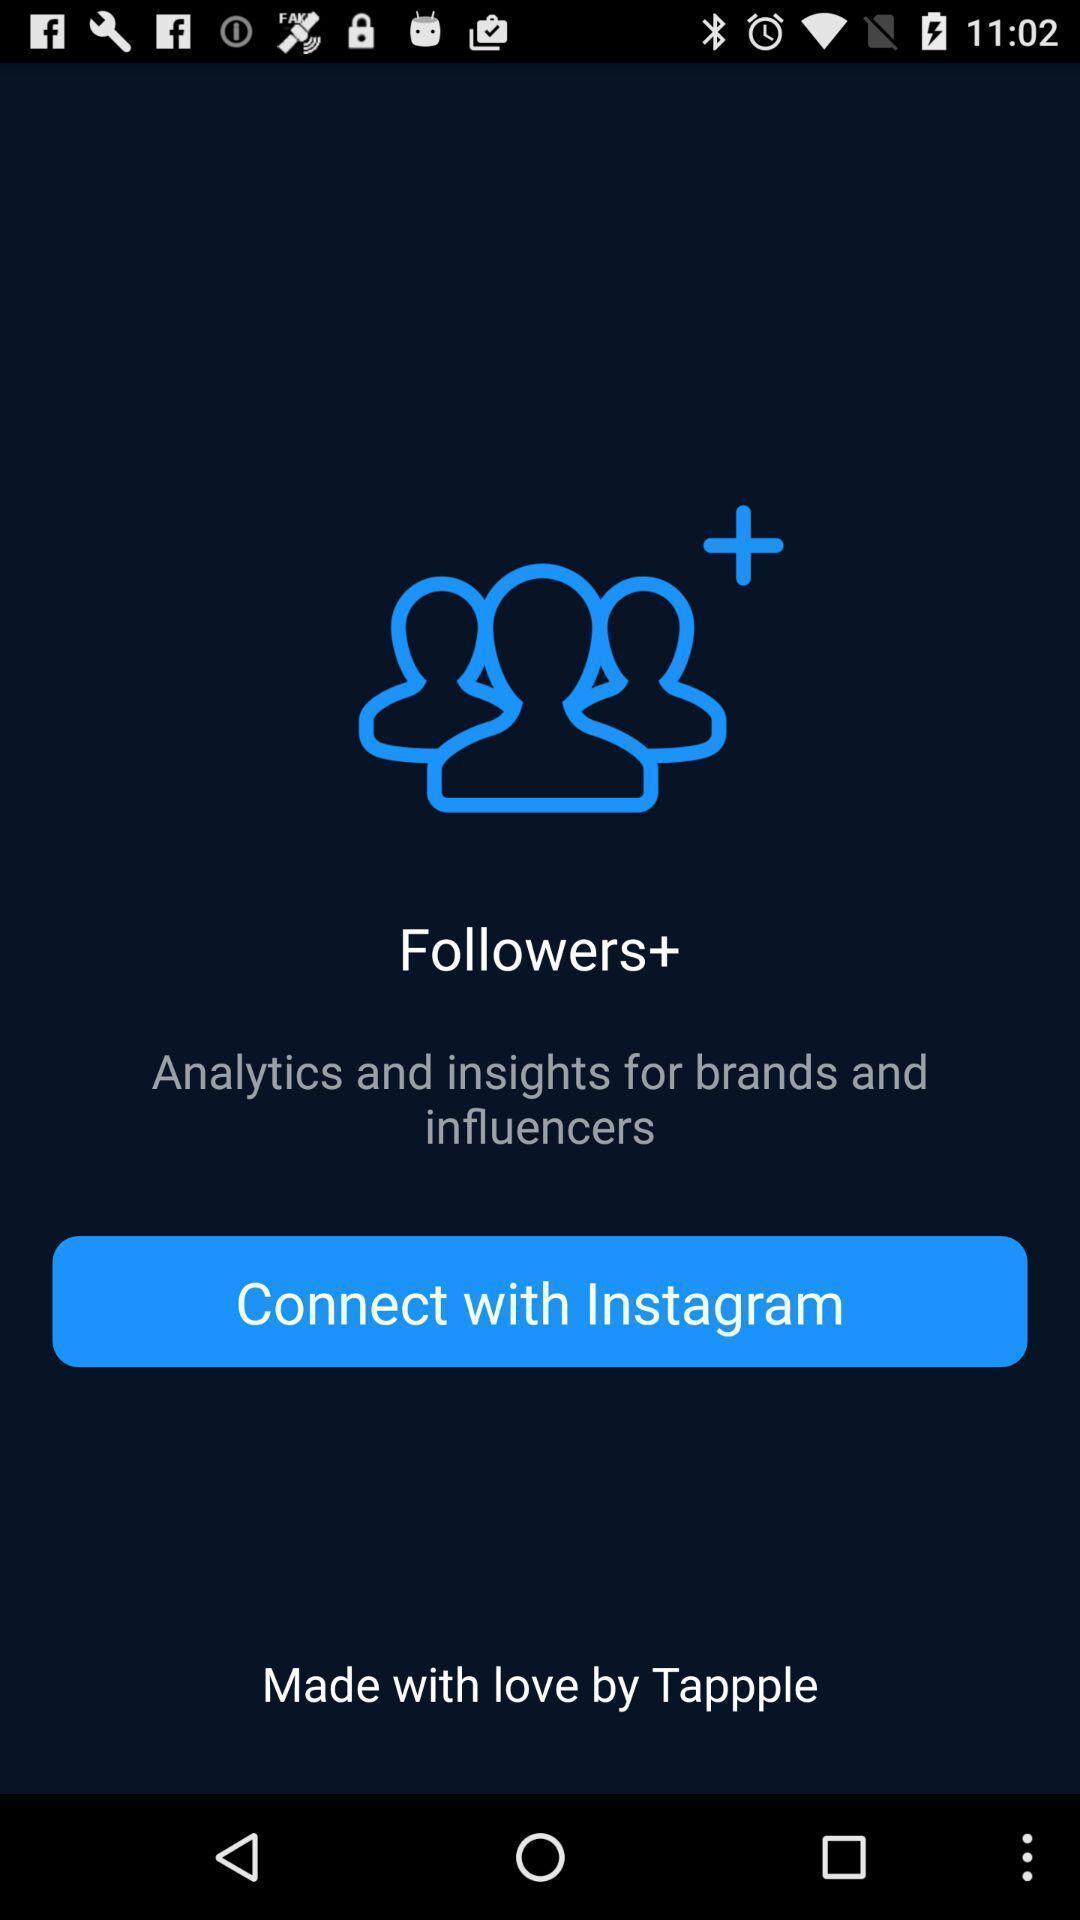Please provide a description for this image. Page displayed to connect to social application. 